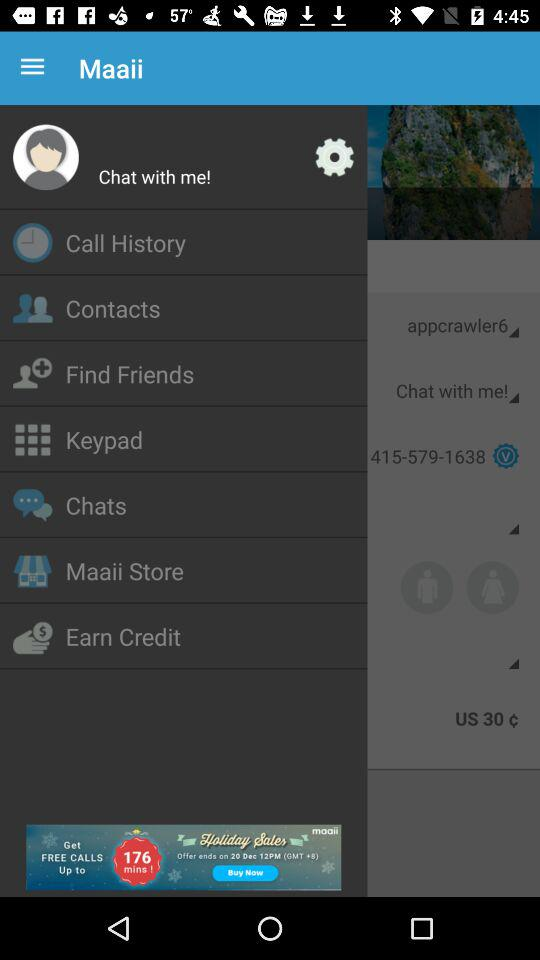What is the email address?
When the provided information is insufficient, respond with <no answer>. <no answer> 